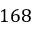Convert formula to latex. <formula><loc_0><loc_0><loc_500><loc_500>1 6 8</formula> 